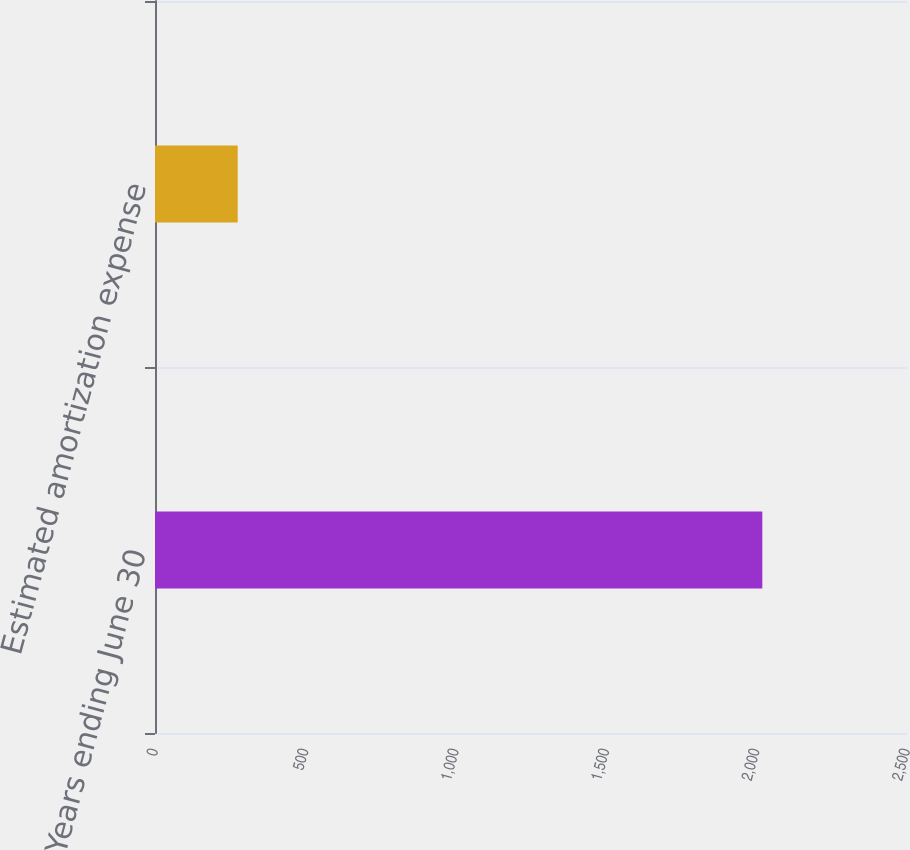<chart> <loc_0><loc_0><loc_500><loc_500><bar_chart><fcel>Years ending June 30<fcel>Estimated amortization expense<nl><fcel>2019<fcel>275<nl></chart> 